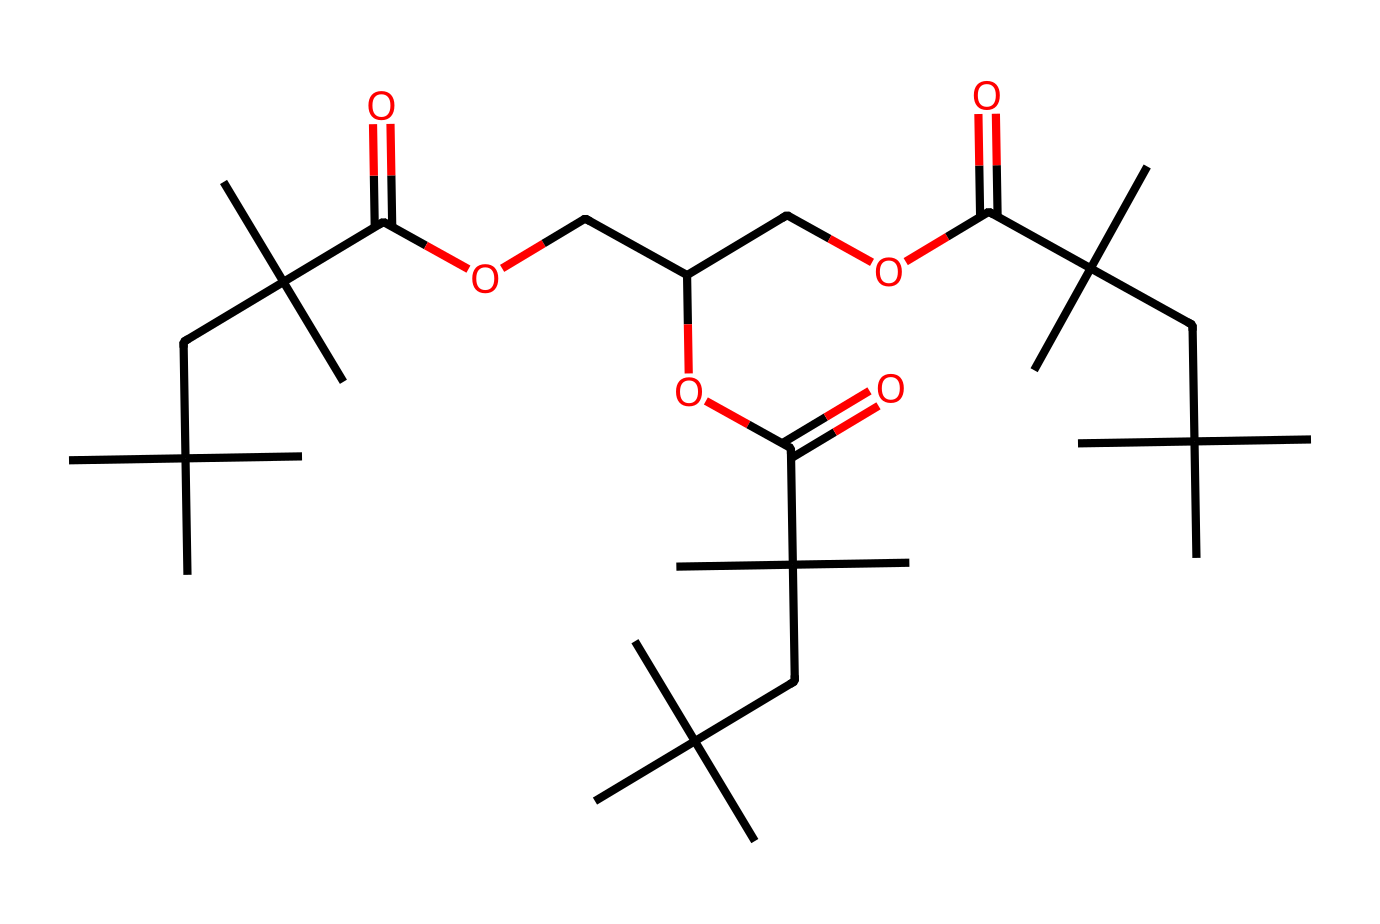What is the main functional group in this polymer? The structure shows a carboxylic acid group (-COOH) through the presence of the carbonyl (C=O) and the hydroxyl (OH) group, indicating a carboxylic acid functional group.
Answer: carboxylic acid How many carbon atoms are present in the structure? By analyzing the SMILES representation, we count the occurrences of the carbon atoms. In this case, there are 30 carbon atoms forming a branched structure in the polymer.
Answer: 30 What type of polymer does this structure represent? The presence of long-chain carbon segments and ester linkages suggests that this represents a poly(ester), a common type of polymer used in various applications.
Answer: poly(ester) What is the degree of branching in this polymer? The polymer features multiple branching points shown by tert-butyl groups (C(C)(C) groups) that make it highly branched instead of linear, reflecting significant branching in the oily composition.
Answer: highly branched What are the main physical properties expected from this polymer? Due to its structure, the polymer is expected to have properties like flexibility, durability, and resistance to heat, which are typical for polymers designed for disposable applications.
Answer: flexible, durable, heat-resistant 